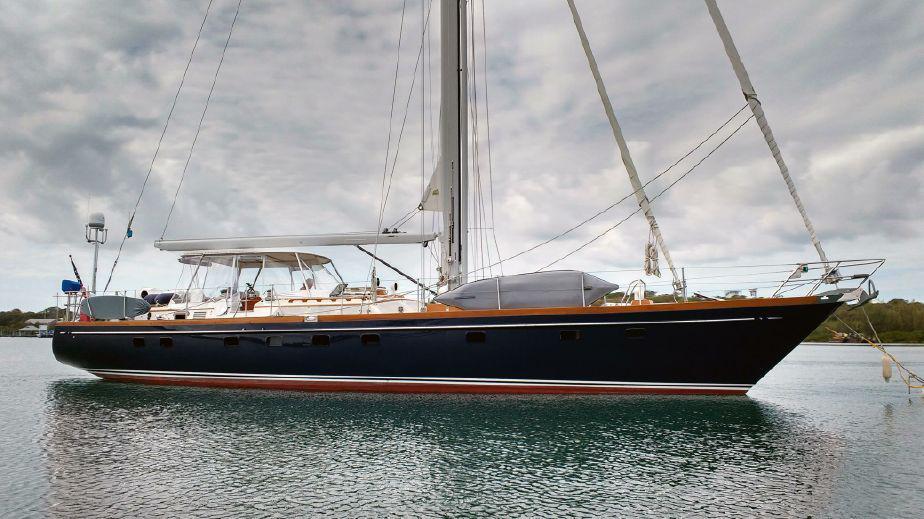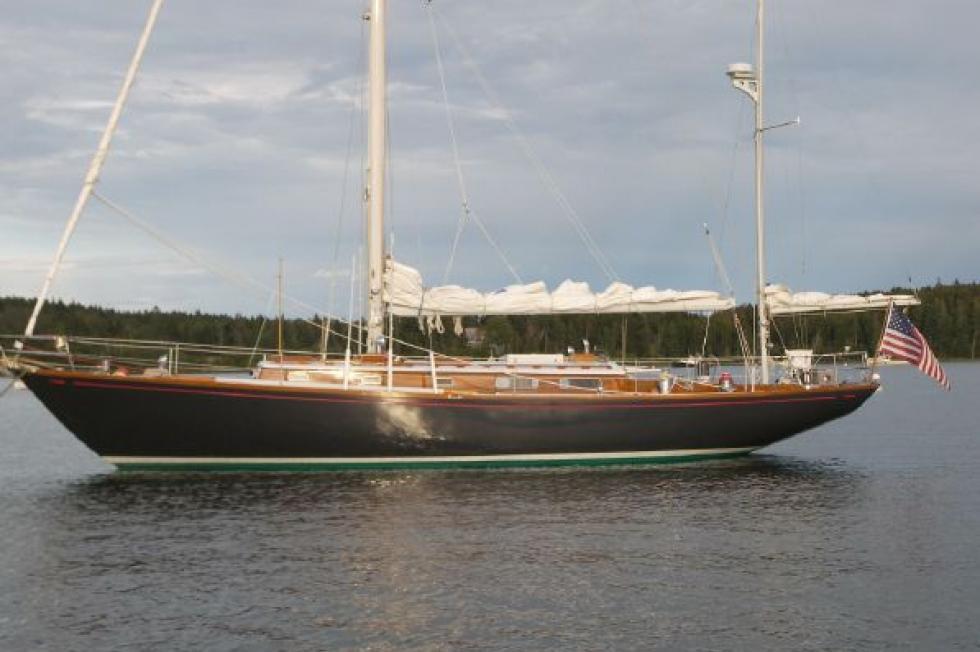The first image is the image on the left, the second image is the image on the right. For the images displayed, is the sentence "There are three white sails up on the boat in the image on the left." factually correct? Answer yes or no. No. The first image is the image on the left, the second image is the image on the right. Given the left and right images, does the statement "A sailboat with three unfurled sails in moving through open water with a man wearing a red coat riding at the back." hold true? Answer yes or no. No. 